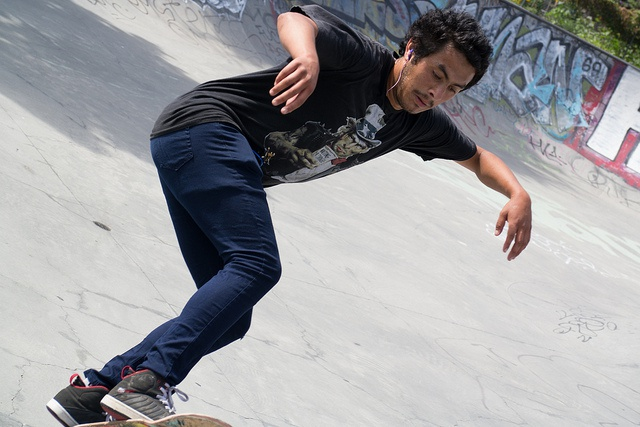Describe the objects in this image and their specific colors. I can see people in gray, black, navy, and lightgray tones and skateboard in gray and ivory tones in this image. 